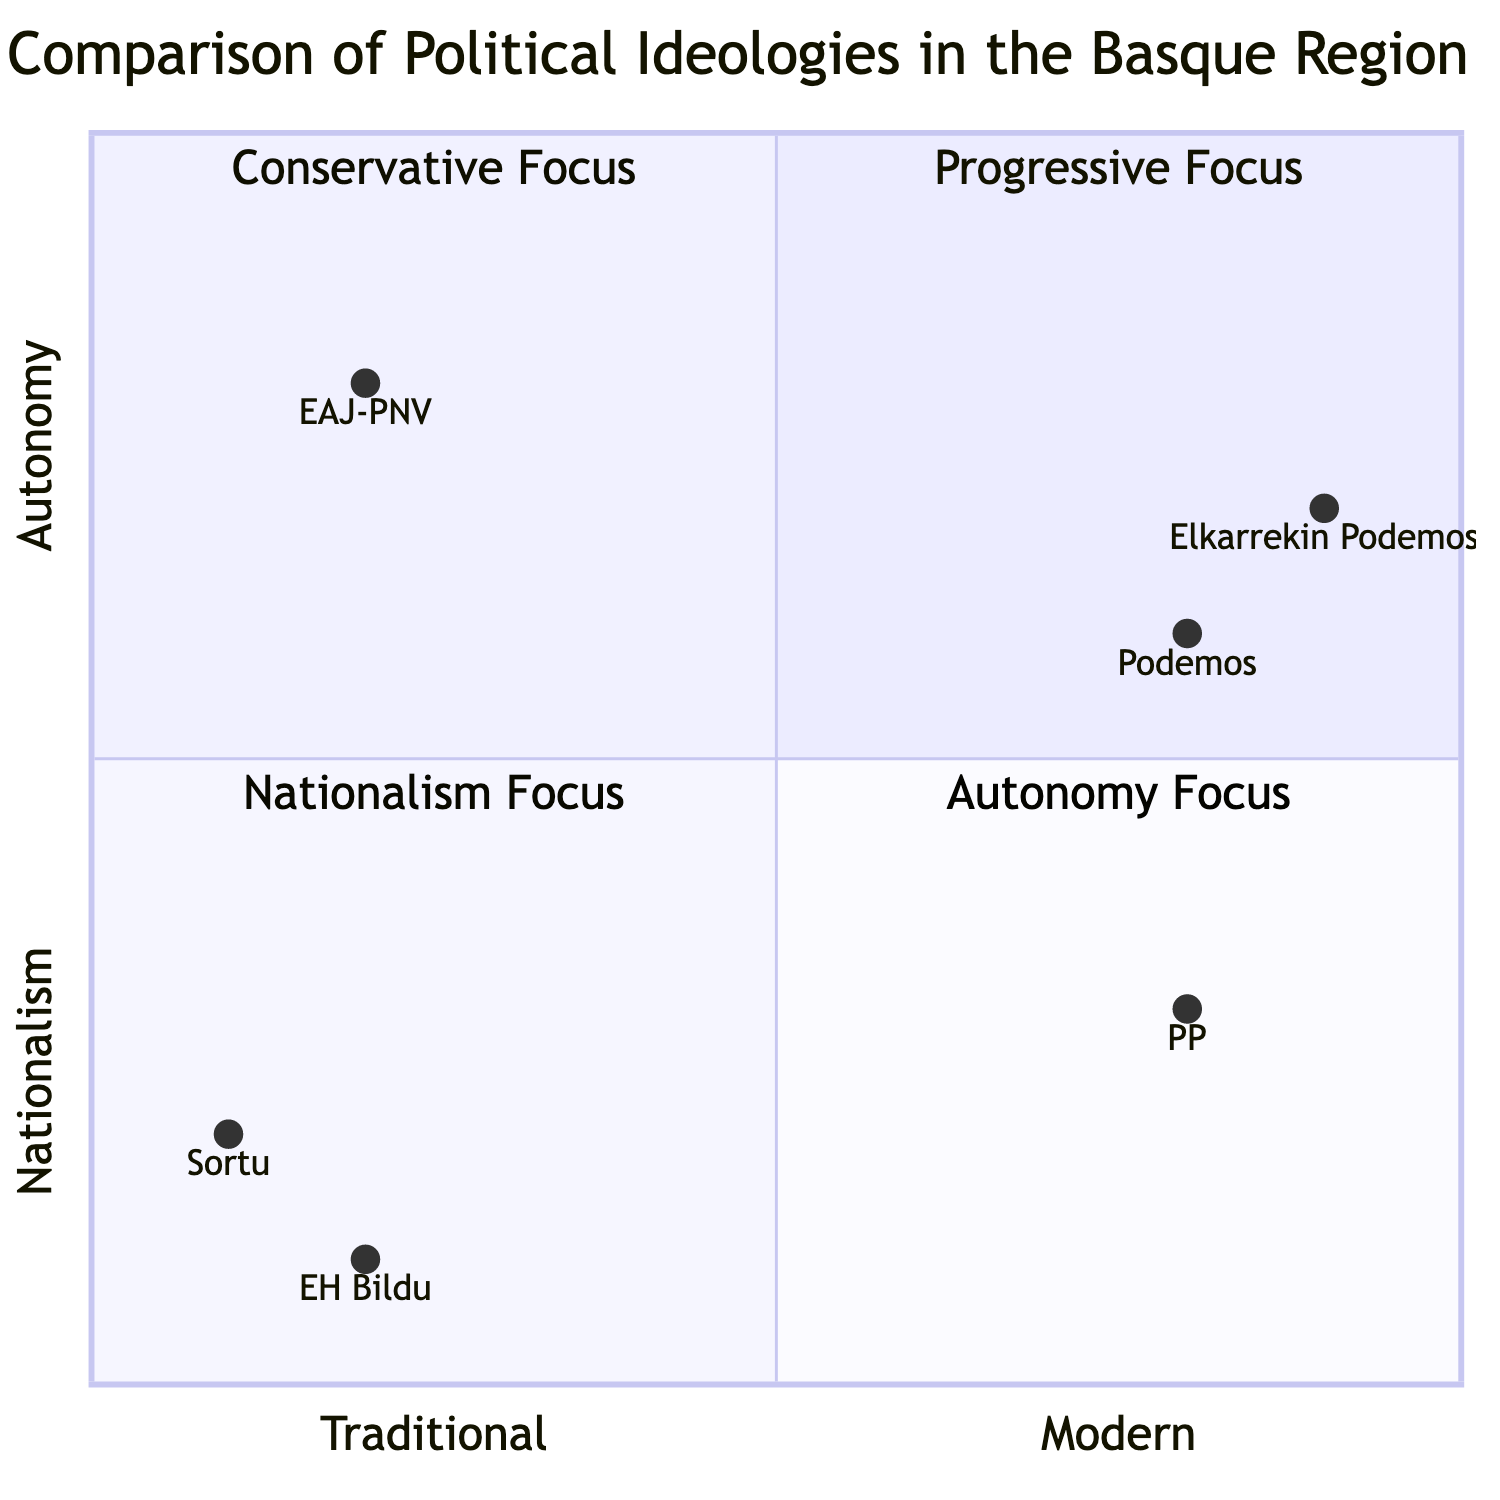What political party is located in the Autonomy Focus quadrant? In the diagram, the Autonomy Focus quadrant corresponds to the traditional perspectives on political ideologies in the Basque region. The only party mentioned in this quadrant is EAJ-PNV.
Answer: EAJ-PNV Which quadrant does Podemos belong to? The party Podemos is located in the quadrant identified as Progressive Focus, which is part of the Modern Perspectives. This is determined by its position on the quadrant chart at coordinates consistent with that quadrant.
Answer: Progressive Focus What is the key figure associated with Sortu? Sortu is positioned in the Nationalism Focus quadrant. From the description provided, the key figure linked to Sortu is Arnaldo Otegi.
Answer: Arnaldo Otegi How many political parties are associated with the Conservative Focus quadrant? The Conservative Focus quadrant includes only one political party mentioned in the diagram, which is the PP (People's Party). Thus, the count is singular.
Answer: 1 What is the economic policy linked with Elkarrekin Podemos? Elkarrekin Podemos is placed in the Progressive Focus quadrant. The economic policy attributed to them is the Green New Deal, as stated in the information for that quadrant.
Answer: Green New Deal Which political party is the furthest to the right in the diagram? In the diagram, the political party located furthest to the right on the x-axis, which represents the transition from Traditional to Modern perspectives, is Elkarrekin Podemos. This position correlates to a score very close to 1 on that axis.
Answer: Elkarrekin Podemos What cultural policy is advocated by the PP? In the Conservative Focus quadrant, the cultural policy associated with the PP is the promotion of Spanish National Identity according to the details provided for that quadrant.
Answer: Spanish National Identity Which political party is closest to the top of the chart? Examining the y-axis, which represents the transition from Nationalism to Autonomy, Podemos is located highest on the chart, indicated by its coordinates aligning closer to the upper edge of the diagram.
Answer: Podemos 